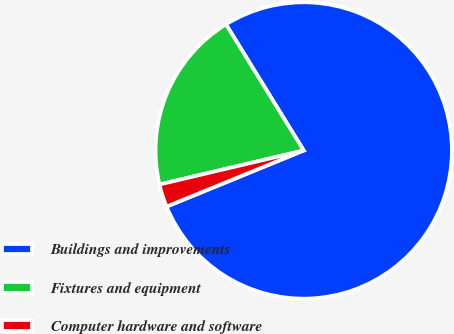Convert chart. <chart><loc_0><loc_0><loc_500><loc_500><pie_chart><fcel>Buildings and improvements<fcel>Fixtures and equipment<fcel>Computer hardware and software<nl><fcel>77.61%<fcel>19.89%<fcel>2.5%<nl></chart> 